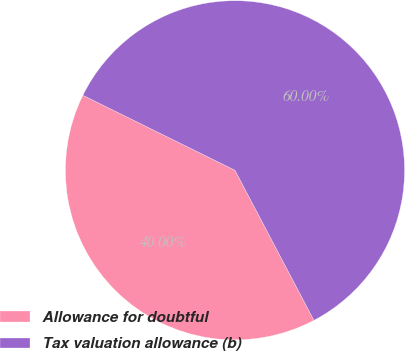<chart> <loc_0><loc_0><loc_500><loc_500><pie_chart><fcel>Allowance for doubtful<fcel>Tax valuation allowance (b)<nl><fcel>40.0%<fcel>60.0%<nl></chart> 